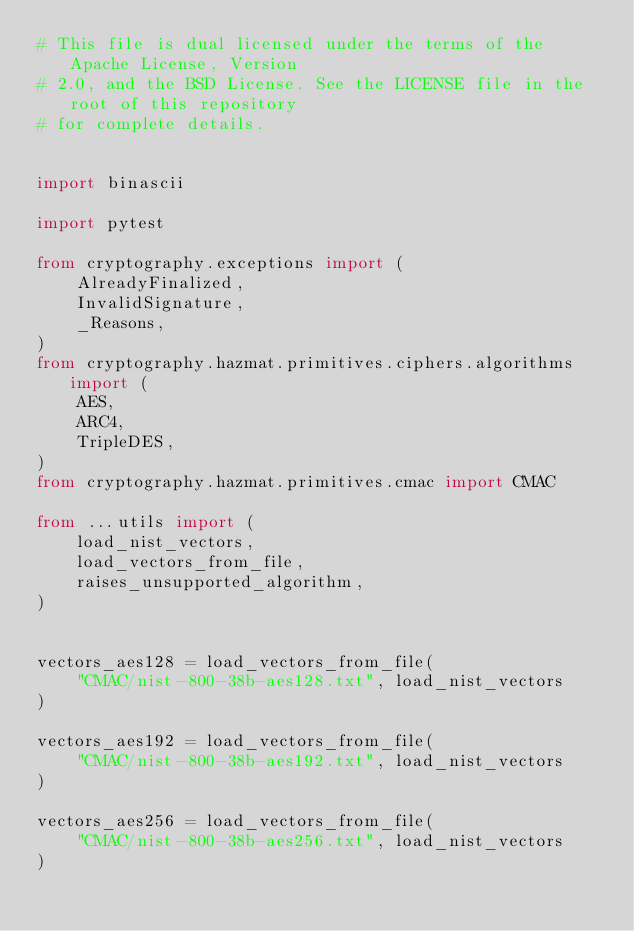<code> <loc_0><loc_0><loc_500><loc_500><_Python_># This file is dual licensed under the terms of the Apache License, Version
# 2.0, and the BSD License. See the LICENSE file in the root of this repository
# for complete details.


import binascii

import pytest

from cryptography.exceptions import (
    AlreadyFinalized,
    InvalidSignature,
    _Reasons,
)
from cryptography.hazmat.primitives.ciphers.algorithms import (
    AES,
    ARC4,
    TripleDES,
)
from cryptography.hazmat.primitives.cmac import CMAC

from ...utils import (
    load_nist_vectors,
    load_vectors_from_file,
    raises_unsupported_algorithm,
)


vectors_aes128 = load_vectors_from_file(
    "CMAC/nist-800-38b-aes128.txt", load_nist_vectors
)

vectors_aes192 = load_vectors_from_file(
    "CMAC/nist-800-38b-aes192.txt", load_nist_vectors
)

vectors_aes256 = load_vectors_from_file(
    "CMAC/nist-800-38b-aes256.txt", load_nist_vectors
)
</code> 